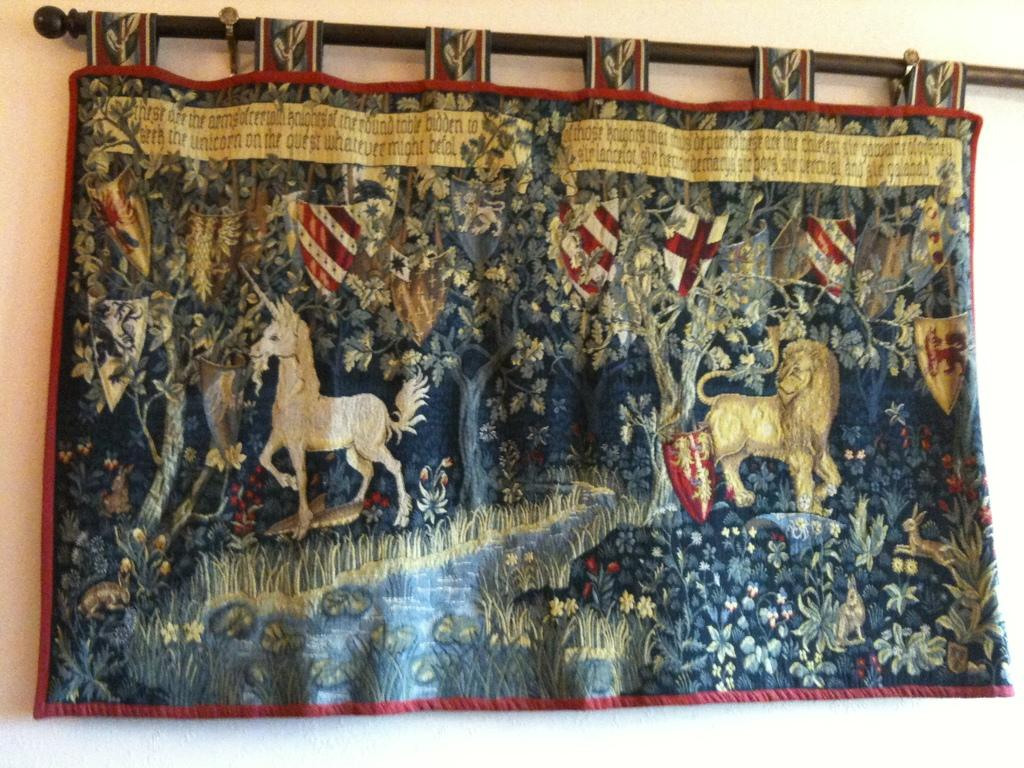What is hanging on a rod in the image? There is a curtain hung on a rod in the image. What images are depicted on the curtain? The curtain has an image of a lion and a horse, as well as other unspecified images. What is behind the curtain in the image? There is a wall behind the curtain in the image. What type of pan is being used to cook the dress in the image? There is no pan or dress present in the image; it features a curtain with images of a lion and a horse, as well as other unspecified images. 